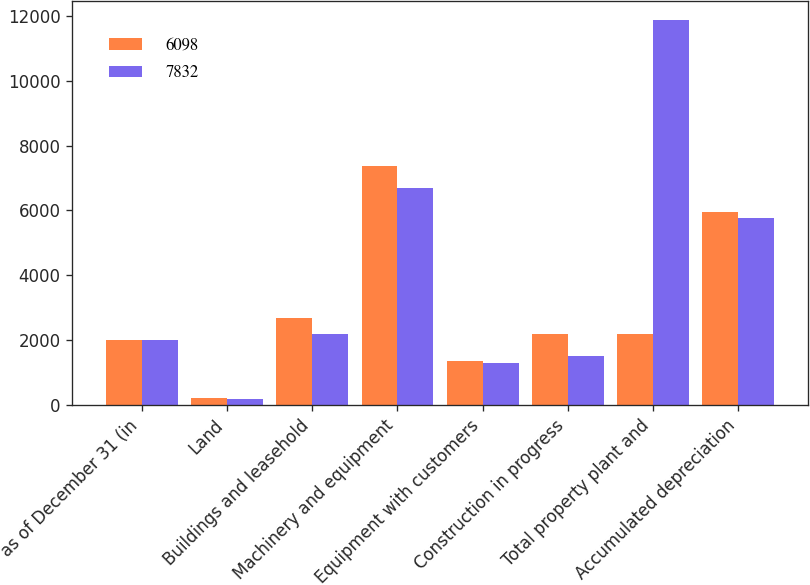Convert chart. <chart><loc_0><loc_0><loc_500><loc_500><stacked_bar_chart><ecel><fcel>as of December 31 (in<fcel>Land<fcel>Buildings and leasehold<fcel>Machinery and equipment<fcel>Equipment with customers<fcel>Construction in progress<fcel>Total property plant and<fcel>Accumulated depreciation<nl><fcel>6098<fcel>2013<fcel>220<fcel>2670<fcel>7360<fcel>1361<fcel>2184<fcel>2181<fcel>5963<nl><fcel>7832<fcel>2012<fcel>190<fcel>2181<fcel>6691<fcel>1295<fcel>1512<fcel>11869<fcel>5771<nl></chart> 